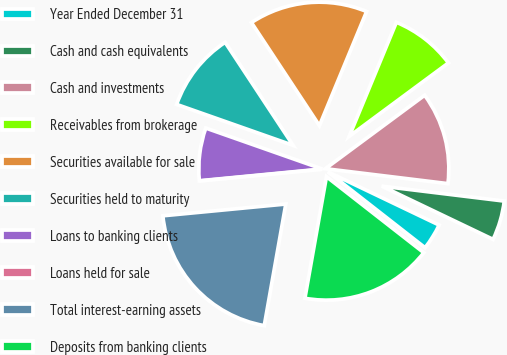<chart> <loc_0><loc_0><loc_500><loc_500><pie_chart><fcel>Year Ended December 31<fcel>Cash and cash equivalents<fcel>Cash and investments<fcel>Receivables from brokerage<fcel>Securities available for sale<fcel>Securities held to maturity<fcel>Loans to banking clients<fcel>Loans held for sale<fcel>Total interest-earning assets<fcel>Deposits from banking clients<nl><fcel>3.45%<fcel>5.17%<fcel>12.07%<fcel>8.62%<fcel>15.52%<fcel>10.34%<fcel>6.9%<fcel>0.0%<fcel>20.69%<fcel>17.24%<nl></chart> 